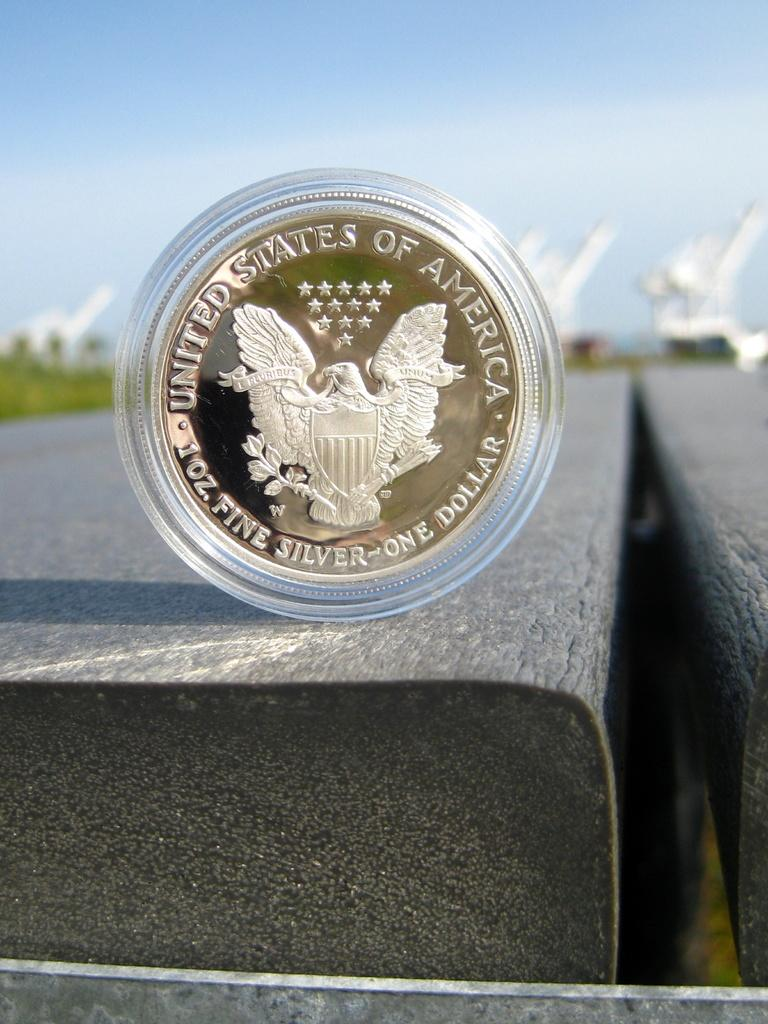<image>
Present a compact description of the photo's key features. a one dollar coin is displayed in a clear plastic case 